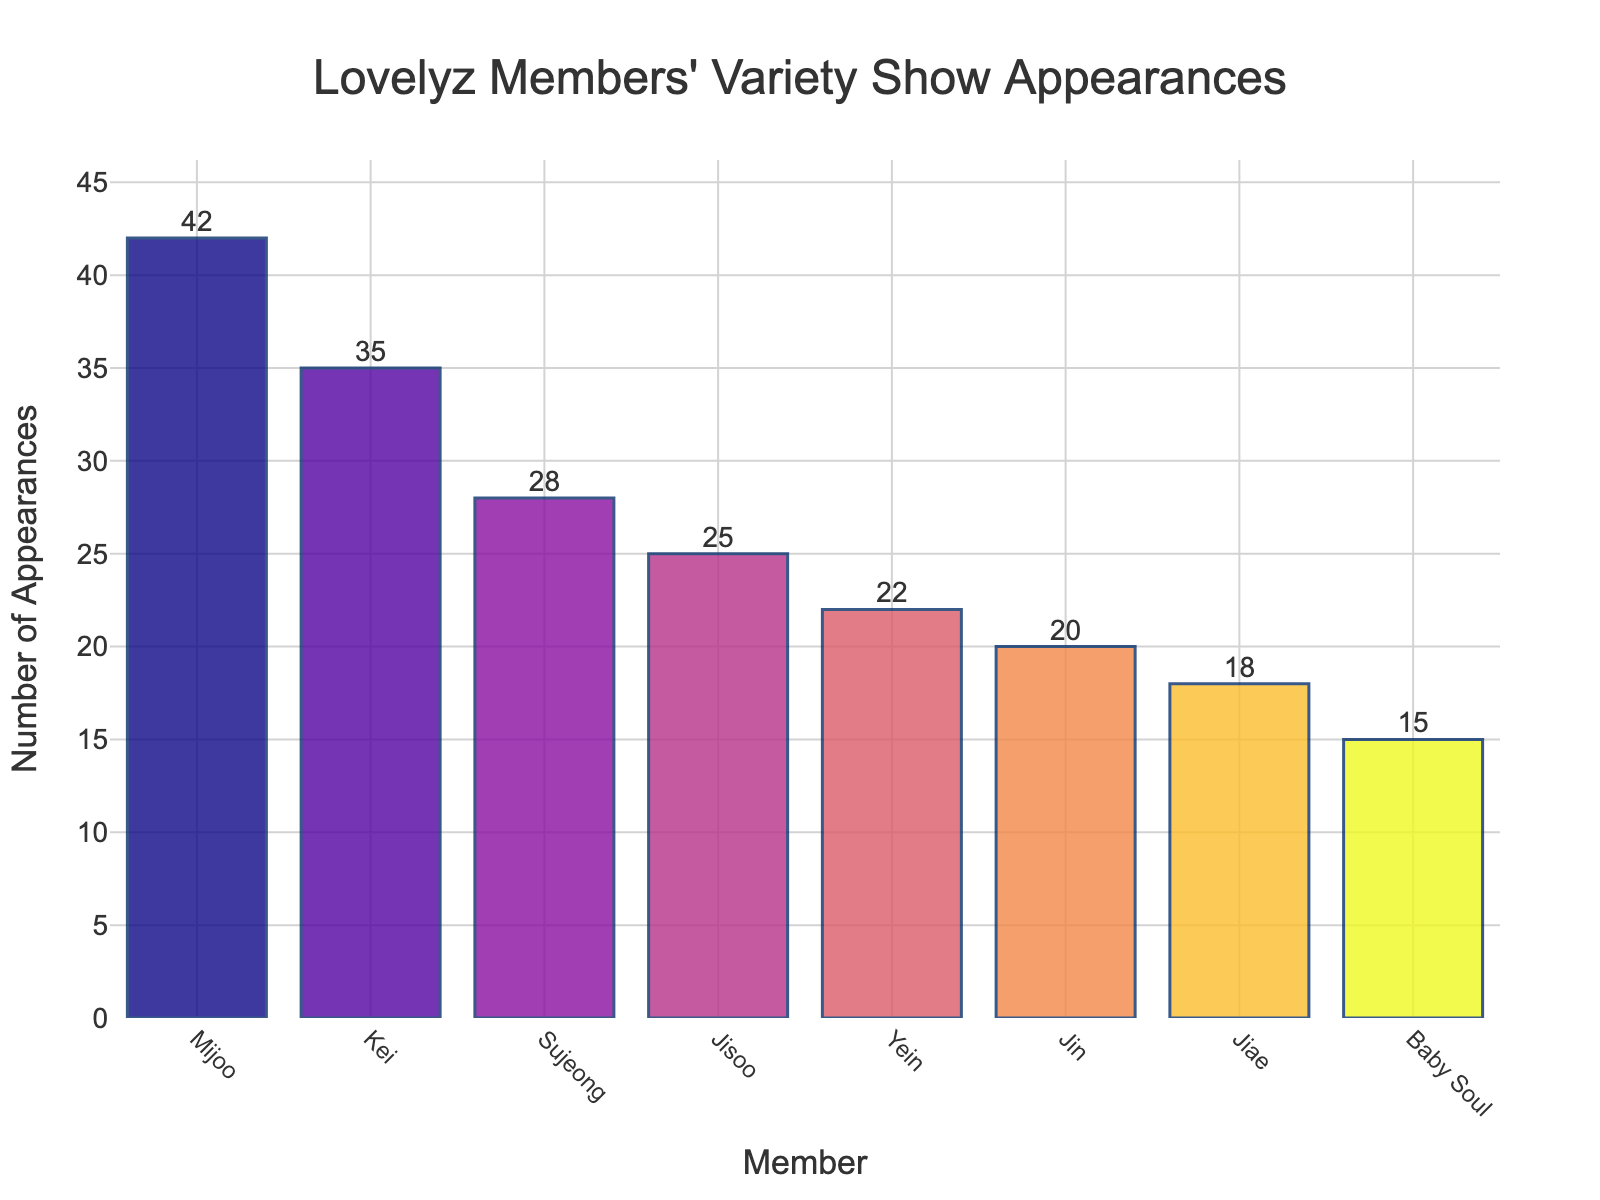What is the total number of variety show appearances by all members? Add the number of variety show appearances of all the members: 42 (Mijoo) + 35 (Kei) + 28 (Sujeong) + 25 (Jisoo) + 22 (Yein) + 20 (Jin) + 18 (Jiae) + 15 (Baby Soul) = 205
Answer: 205 Which member has the highest number of variety show appearances? Look at the bar with the greatest height, which corresponds to Mijoo with 42 appearances
Answer: Mijoo How many more variety show appearances does Mijoo have compared to Baby Soul? Subtract Baby Soul's appearances from Mijoo's appearances: 42 (Mijoo) - 15 (Baby Soul) = 27
Answer: 27 How many members have participated in at least 25 variety shows? Count the members whose appearances are 25 or more: Mijoo (42), Kei (35), Sujeong (28), Jisoo (25). So, 4 members
Answer: 4 What percentage of the total variety show appearances does Kei have? Divide Kei's appearances by the total and multiply by 100: (35 / 205) * 100 ≈ 17.07%
Answer: 17.07% How does Jisoo's number of appearances compare to Yein's number of appearances? Subtract Yein's appearances from Jisoo's appearances: 25 (Jisoo) - 22 (Yein) = 3
Answer: 3 more Which members have fewer than 20 variety show appearances? Identify the members whose appearances are less than 20: Jiae (18) and Baby Soul (15)
Answer: Jiae and Baby Soul What is the average number of appearances per member? Divide the total number of appearances by the number of members: 205 / 8 ≈ 25.63
Answer: 25.63 How many variety show appearances separate Sujeong and Jisoo? Subtract Jisoo's appearances from Sujeong's appearances: 28 (Sujeong) - 25 (Jisoo) = 3
Answer: 3 What is the combined number of appearances for members with fewer than 25 appearances? Add the appearances of members with fewer than 25 appearances: 22 (Yein) + 20 (Jin) + 18 (Jiae) + 15 (Baby Soul) = 75
Answer: 75 